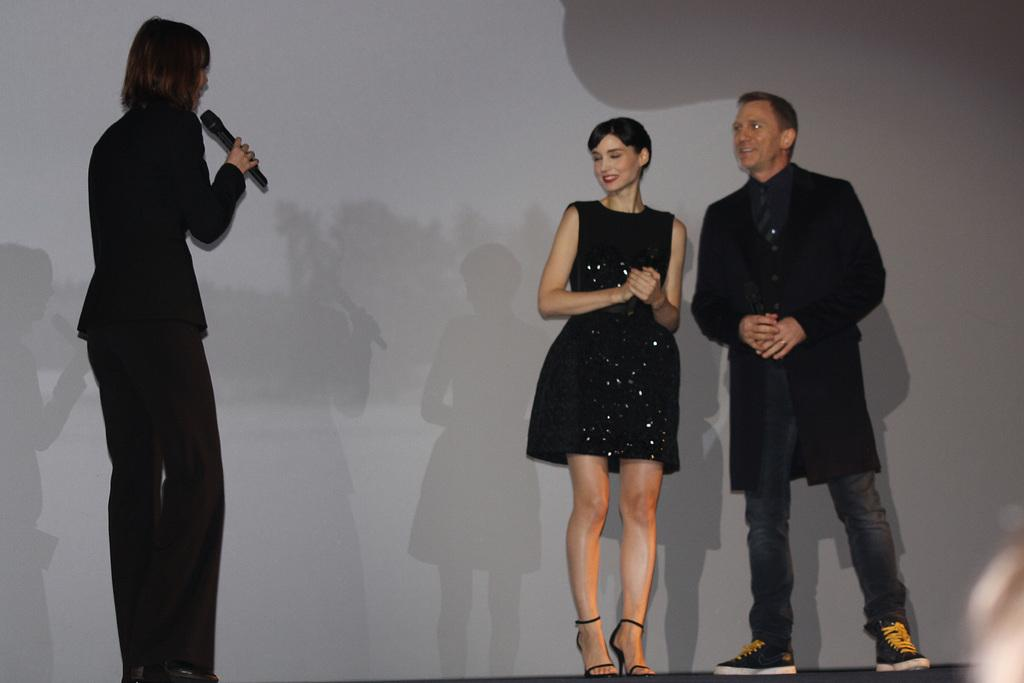How many people are present in the image? There are three people standing in the image. What is the woman holding in the image? The woman is holding a microphone. What can be observed about the shadows in the image? The woman's shadow and the shadows of the other two people are falling on the wall. What type of mass control is the woman demonstrating in the image? There is no indication of mass control in the image; the woman is simply holding a microphone. Can you see a banana in the image? There is no banana present in the image. 